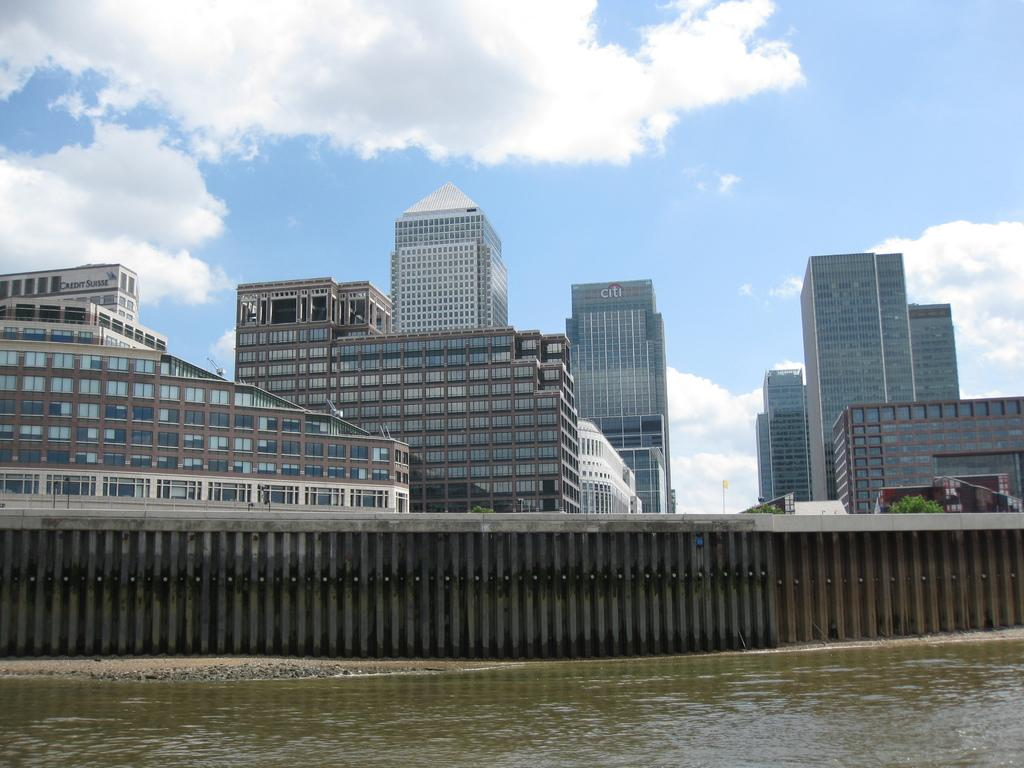What type of structures can be seen in the image? There are buildings in the image. What natural element is visible in the image? There is water visible in the image. What part of the natural environment is visible in the image? The sky is visible in the image. What type of flag is visible in the image? There is no flag present in the image. How many stars can be seen in the image? There are no stars visible in the image. 